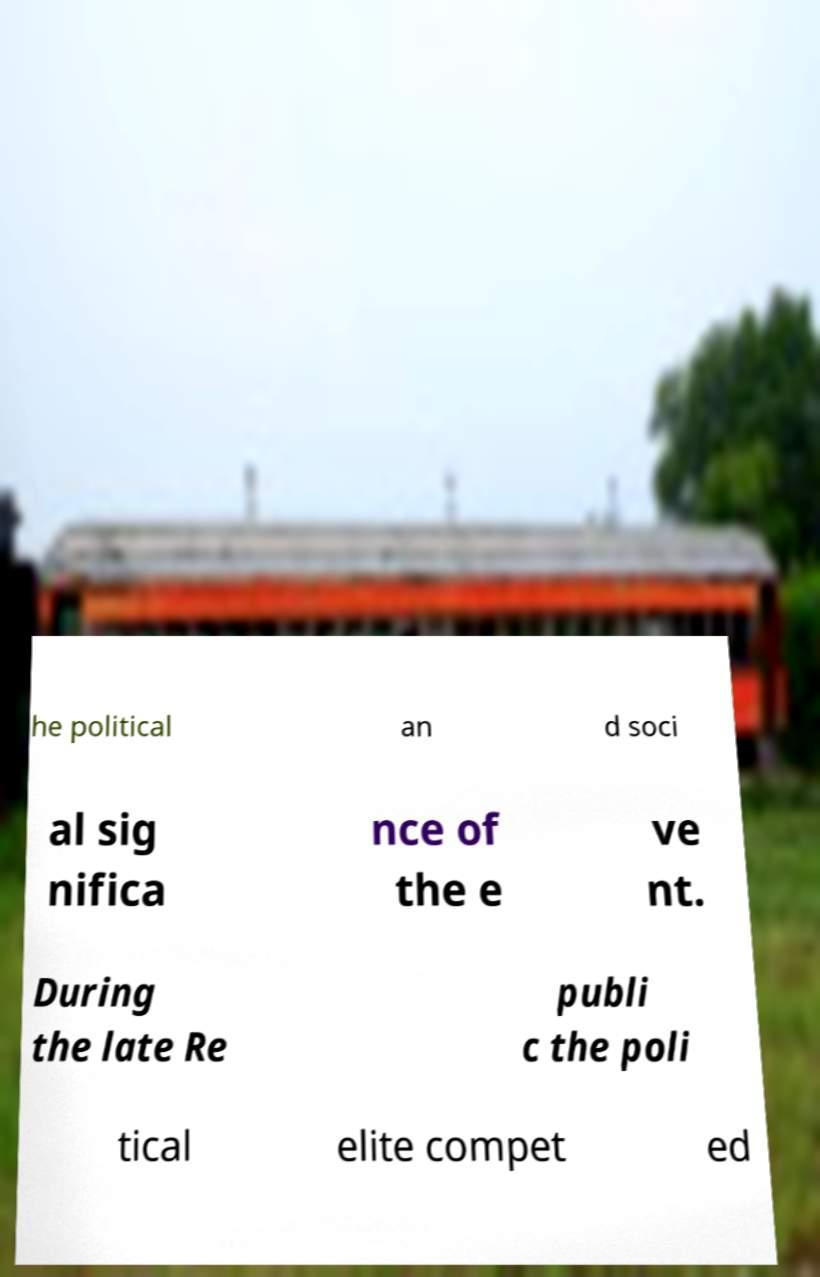Please identify and transcribe the text found in this image. he political an d soci al sig nifica nce of the e ve nt. During the late Re publi c the poli tical elite compet ed 